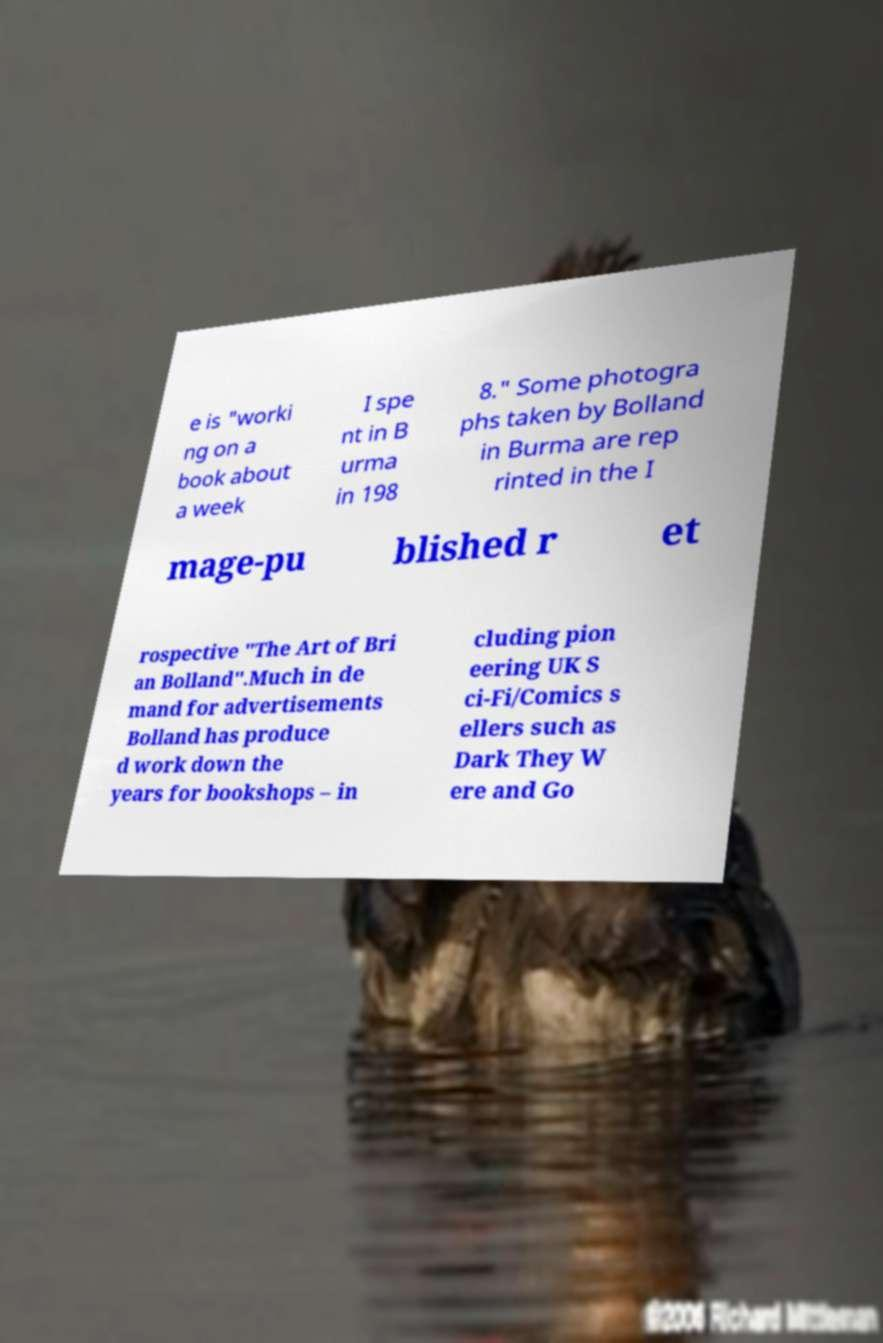For documentation purposes, I need the text within this image transcribed. Could you provide that? e is "worki ng on a book about a week I spe nt in B urma in 198 8." Some photogra phs taken by Bolland in Burma are rep rinted in the I mage-pu blished r et rospective "The Art of Bri an Bolland".Much in de mand for advertisements Bolland has produce d work down the years for bookshops – in cluding pion eering UK S ci-Fi/Comics s ellers such as Dark They W ere and Go 